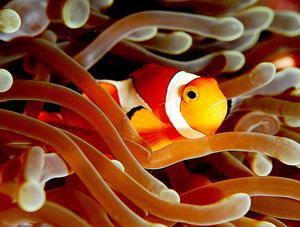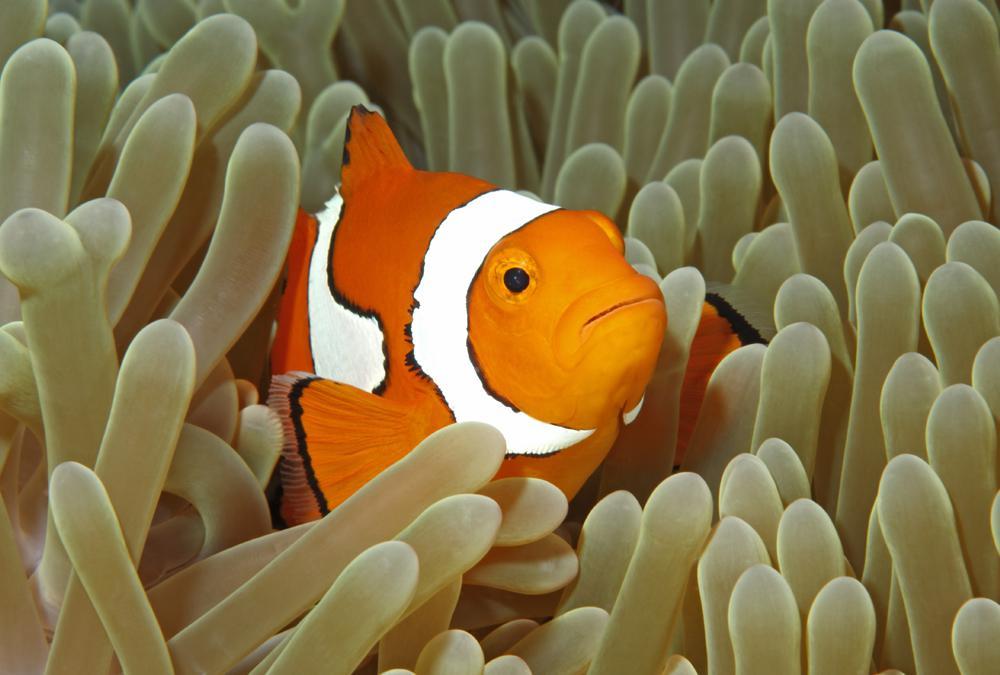The first image is the image on the left, the second image is the image on the right. Assess this claim about the two images: "Exactly two clown fish swim through anemone tendrils in one image.". Correct or not? Answer yes or no. No. 